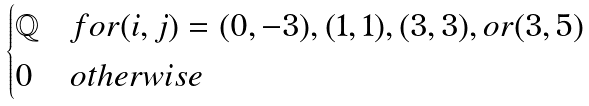<formula> <loc_0><loc_0><loc_500><loc_500>\begin{cases} \mathbb { Q } & f o r ( i , j ) = ( 0 , - 3 ) , ( 1 , 1 ) , ( 3 , 3 ) , o r ( 3 , 5 ) \\ 0 & o t h e r w i s e \end{cases}</formula> 